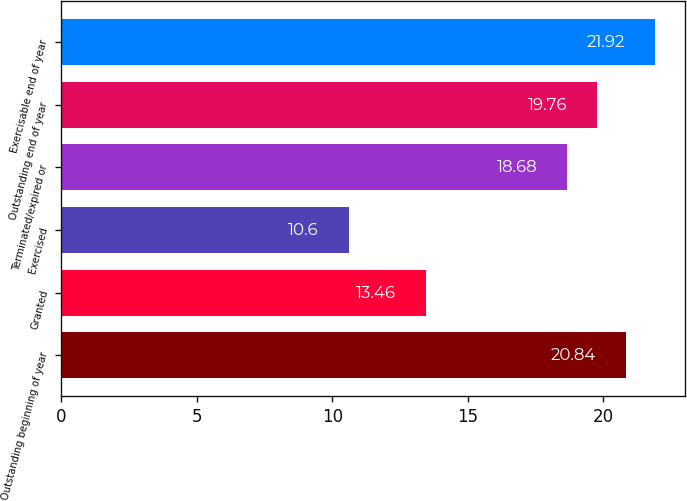<chart> <loc_0><loc_0><loc_500><loc_500><bar_chart><fcel>Outstanding beginning of year<fcel>Granted<fcel>Exercised<fcel>Terminated/expired or<fcel>Outstanding end of year<fcel>Exercisable end of year<nl><fcel>20.84<fcel>13.46<fcel>10.6<fcel>18.68<fcel>19.76<fcel>21.92<nl></chart> 